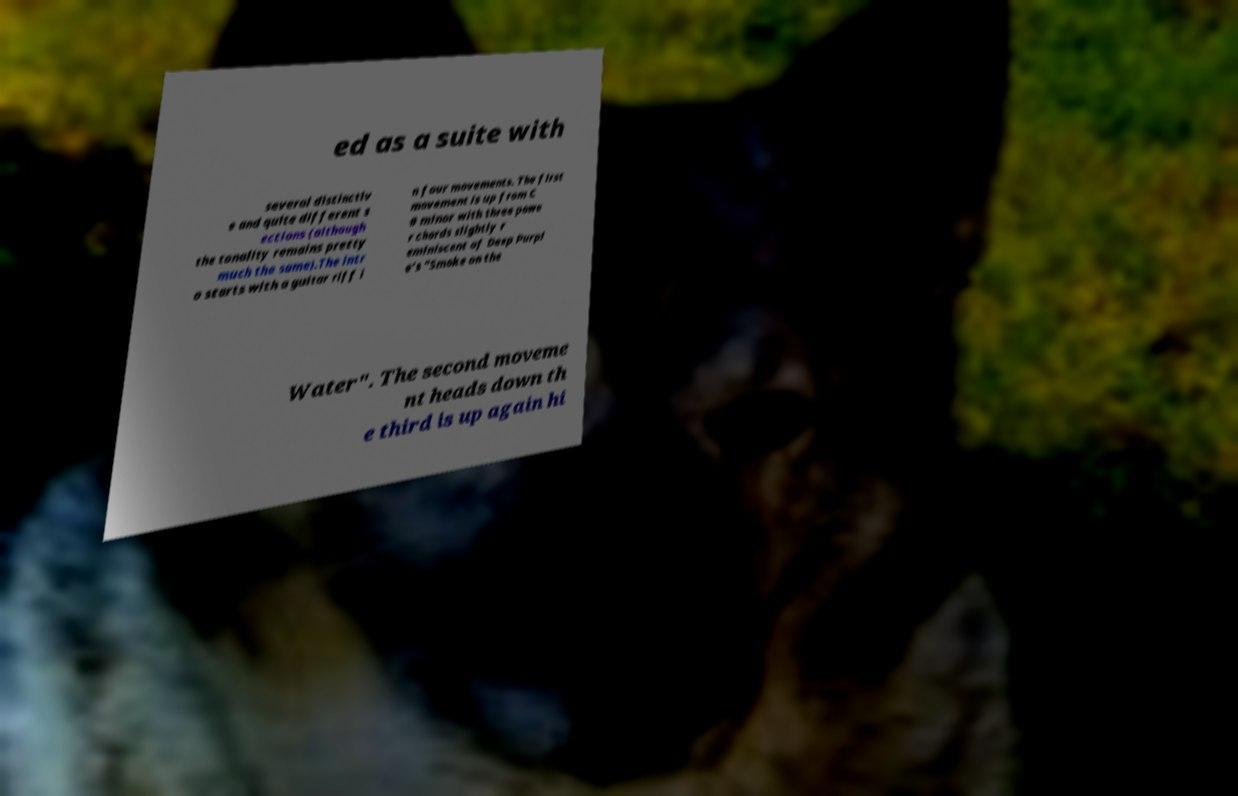What messages or text are displayed in this image? I need them in a readable, typed format. ed as a suite with several distinctiv e and quite different s ections (although the tonality remains pretty much the same).The intr o starts with a guitar riff i n four movements. The first movement is up from C # minor with three powe r chords slightly r eminiscent of Deep Purpl e's "Smoke on the Water". The second moveme nt heads down th e third is up again hi 